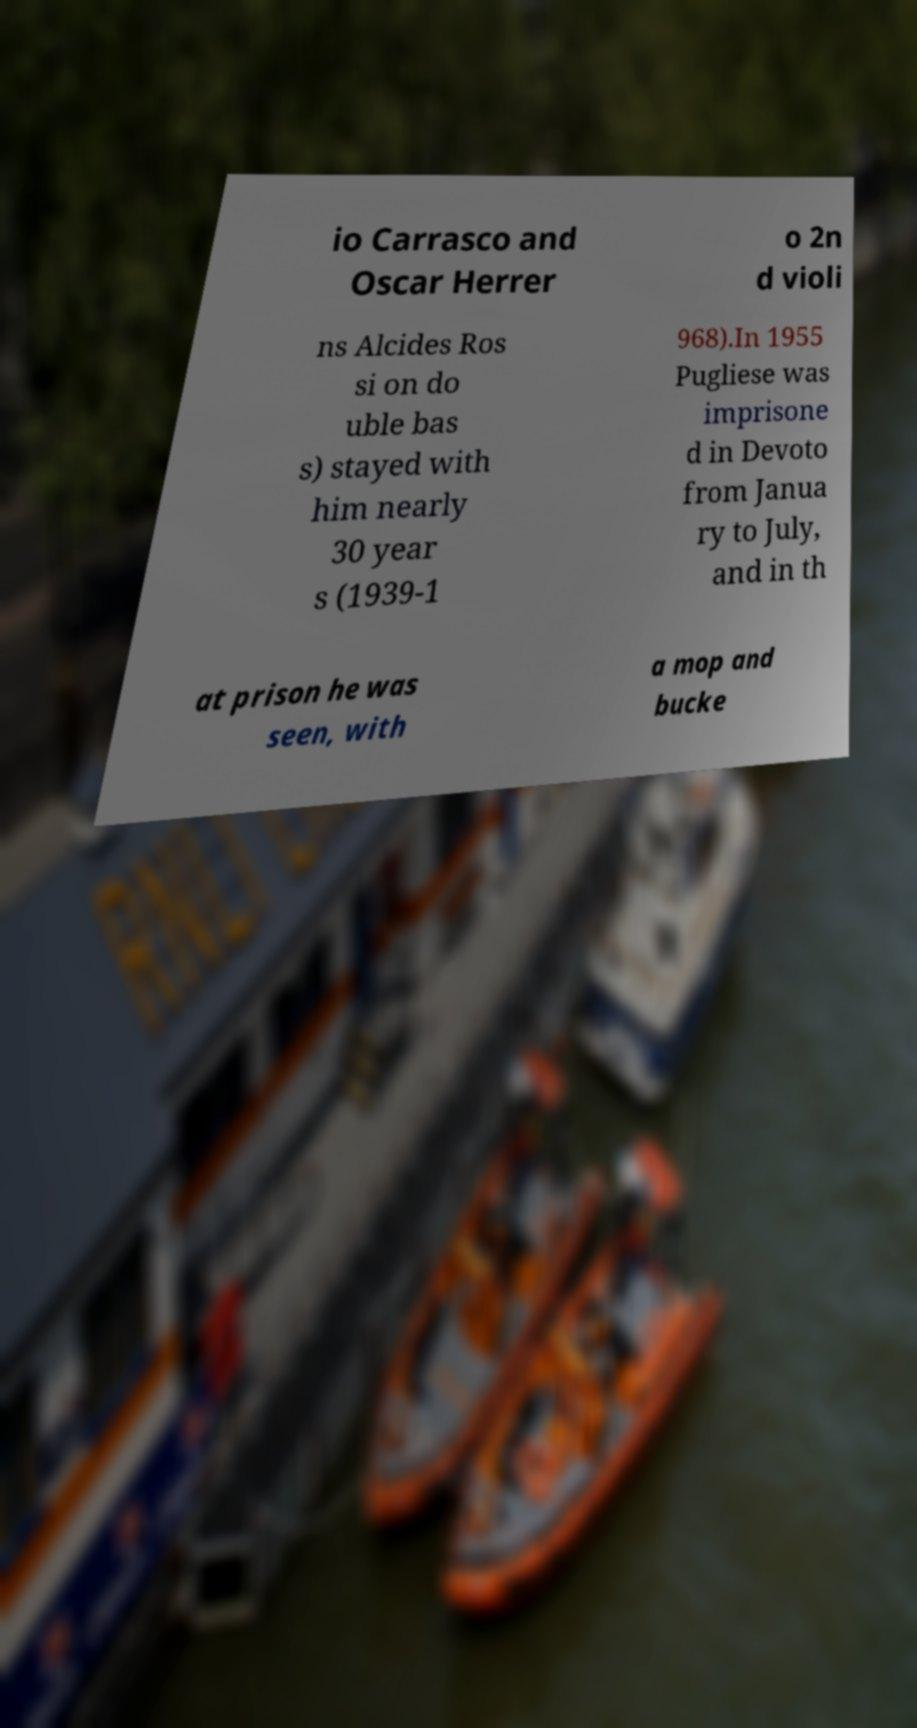What messages or text are displayed in this image? I need them in a readable, typed format. io Carrasco and Oscar Herrer o 2n d violi ns Alcides Ros si on do uble bas s) stayed with him nearly 30 year s (1939-1 968).In 1955 Pugliese was imprisone d in Devoto from Janua ry to July, and in th at prison he was seen, with a mop and bucke 